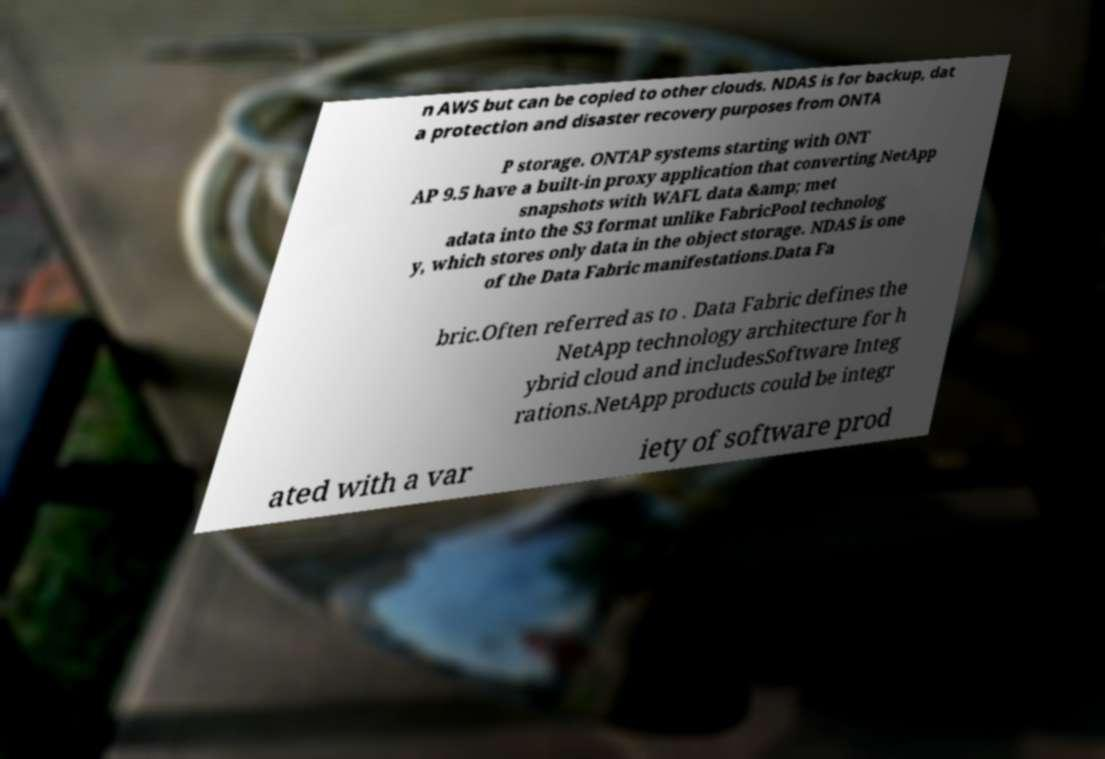Please identify and transcribe the text found in this image. n AWS but can be copied to other clouds. NDAS is for backup, dat a protection and disaster recovery purposes from ONTA P storage. ONTAP systems starting with ONT AP 9.5 have a built-in proxy application that converting NetApp snapshots with WAFL data &amp; met adata into the S3 format unlike FabricPool technolog y, which stores only data in the object storage. NDAS is one of the Data Fabric manifestations.Data Fa bric.Often referred as to . Data Fabric defines the NetApp technology architecture for h ybrid cloud and includesSoftware Integ rations.NetApp products could be integr ated with a var iety of software prod 